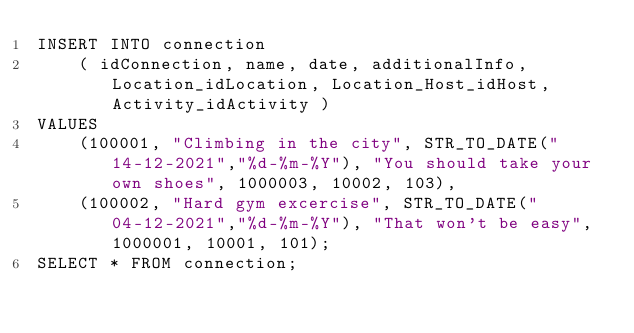Convert code to text. <code><loc_0><loc_0><loc_500><loc_500><_SQL_>INSERT INTO connection
	( idConnection, name, date, additionalInfo, Location_idLocation, Location_Host_idHost, Activity_idActivity )
VALUES
	(100001, "Climbing in the city", STR_TO_DATE("14-12-2021","%d-%m-%Y"), "You should take your own shoes", 1000003, 10002, 103),
    (100002, "Hard gym excercise", STR_TO_DATE("04-12-2021","%d-%m-%Y"), "That won't be easy", 1000001, 10001, 101);
SELECT * FROM connection;</code> 